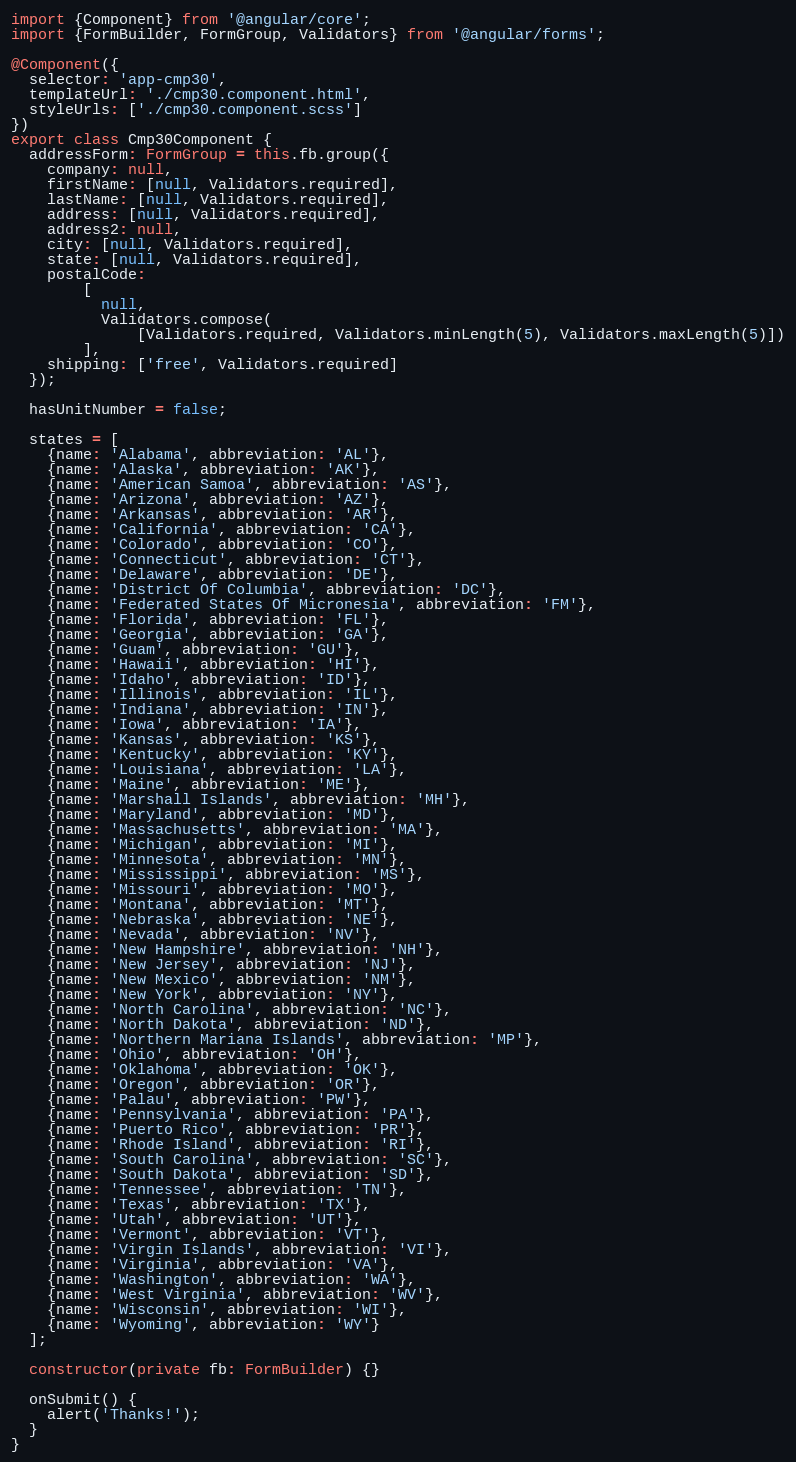<code> <loc_0><loc_0><loc_500><loc_500><_TypeScript_>import {Component} from '@angular/core';
import {FormBuilder, FormGroup, Validators} from '@angular/forms';

@Component({
  selector: 'app-cmp30',
  templateUrl: './cmp30.component.html',
  styleUrls: ['./cmp30.component.scss']
})
export class Cmp30Component {
  addressForm: FormGroup = this.fb.group({
    company: null,
    firstName: [null, Validators.required],
    lastName: [null, Validators.required],
    address: [null, Validators.required],
    address2: null,
    city: [null, Validators.required],
    state: [null, Validators.required],
    postalCode:
        [
          null,
          Validators.compose(
              [Validators.required, Validators.minLength(5), Validators.maxLength(5)])
        ],
    shipping: ['free', Validators.required]
  });

  hasUnitNumber = false;

  states = [
    {name: 'Alabama', abbreviation: 'AL'},
    {name: 'Alaska', abbreviation: 'AK'},
    {name: 'American Samoa', abbreviation: 'AS'},
    {name: 'Arizona', abbreviation: 'AZ'},
    {name: 'Arkansas', abbreviation: 'AR'},
    {name: 'California', abbreviation: 'CA'},
    {name: 'Colorado', abbreviation: 'CO'},
    {name: 'Connecticut', abbreviation: 'CT'},
    {name: 'Delaware', abbreviation: 'DE'},
    {name: 'District Of Columbia', abbreviation: 'DC'},
    {name: 'Federated States Of Micronesia', abbreviation: 'FM'},
    {name: 'Florida', abbreviation: 'FL'},
    {name: 'Georgia', abbreviation: 'GA'},
    {name: 'Guam', abbreviation: 'GU'},
    {name: 'Hawaii', abbreviation: 'HI'},
    {name: 'Idaho', abbreviation: 'ID'},
    {name: 'Illinois', abbreviation: 'IL'},
    {name: 'Indiana', abbreviation: 'IN'},
    {name: 'Iowa', abbreviation: 'IA'},
    {name: 'Kansas', abbreviation: 'KS'},
    {name: 'Kentucky', abbreviation: 'KY'},
    {name: 'Louisiana', abbreviation: 'LA'},
    {name: 'Maine', abbreviation: 'ME'},
    {name: 'Marshall Islands', abbreviation: 'MH'},
    {name: 'Maryland', abbreviation: 'MD'},
    {name: 'Massachusetts', abbreviation: 'MA'},
    {name: 'Michigan', abbreviation: 'MI'},
    {name: 'Minnesota', abbreviation: 'MN'},
    {name: 'Mississippi', abbreviation: 'MS'},
    {name: 'Missouri', abbreviation: 'MO'},
    {name: 'Montana', abbreviation: 'MT'},
    {name: 'Nebraska', abbreviation: 'NE'},
    {name: 'Nevada', abbreviation: 'NV'},
    {name: 'New Hampshire', abbreviation: 'NH'},
    {name: 'New Jersey', abbreviation: 'NJ'},
    {name: 'New Mexico', abbreviation: 'NM'},
    {name: 'New York', abbreviation: 'NY'},
    {name: 'North Carolina', abbreviation: 'NC'},
    {name: 'North Dakota', abbreviation: 'ND'},
    {name: 'Northern Mariana Islands', abbreviation: 'MP'},
    {name: 'Ohio', abbreviation: 'OH'},
    {name: 'Oklahoma', abbreviation: 'OK'},
    {name: 'Oregon', abbreviation: 'OR'},
    {name: 'Palau', abbreviation: 'PW'},
    {name: 'Pennsylvania', abbreviation: 'PA'},
    {name: 'Puerto Rico', abbreviation: 'PR'},
    {name: 'Rhode Island', abbreviation: 'RI'},
    {name: 'South Carolina', abbreviation: 'SC'},
    {name: 'South Dakota', abbreviation: 'SD'},
    {name: 'Tennessee', abbreviation: 'TN'},
    {name: 'Texas', abbreviation: 'TX'},
    {name: 'Utah', abbreviation: 'UT'},
    {name: 'Vermont', abbreviation: 'VT'},
    {name: 'Virgin Islands', abbreviation: 'VI'},
    {name: 'Virginia', abbreviation: 'VA'},
    {name: 'Washington', abbreviation: 'WA'},
    {name: 'West Virginia', abbreviation: 'WV'},
    {name: 'Wisconsin', abbreviation: 'WI'},
    {name: 'Wyoming', abbreviation: 'WY'}
  ];

  constructor(private fb: FormBuilder) {}

  onSubmit() {
    alert('Thanks!');
  }
}
</code> 